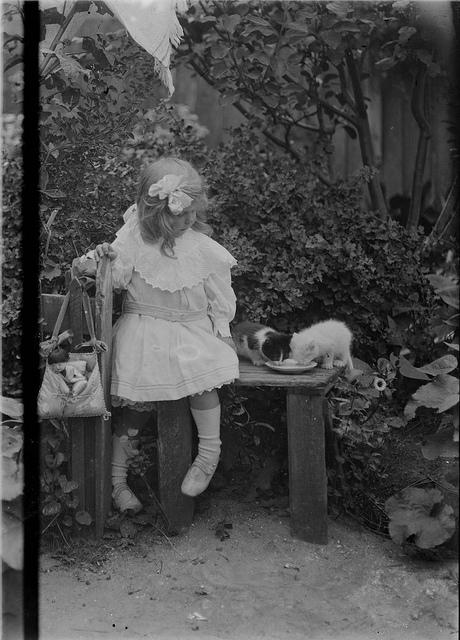How many cats are eating off the plate?
Concise answer only. 2. What kind of collar is on her dress?
Be succinct. Ruffled. Are there more than 3 people in the picture?
Answer briefly. No. Are felines warm blooded animals?
Concise answer only. Yes. 